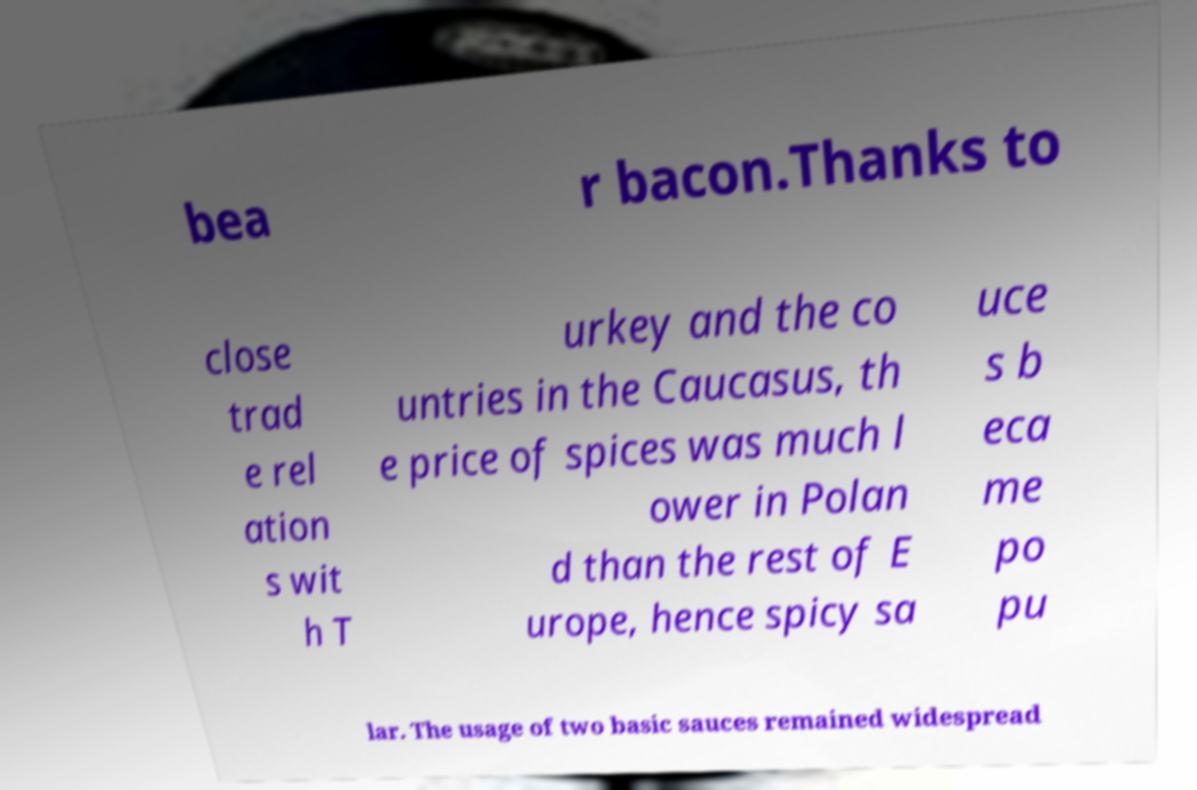For documentation purposes, I need the text within this image transcribed. Could you provide that? bea r bacon.Thanks to close trad e rel ation s wit h T urkey and the co untries in the Caucasus, th e price of spices was much l ower in Polan d than the rest of E urope, hence spicy sa uce s b eca me po pu lar. The usage of two basic sauces remained widespread 